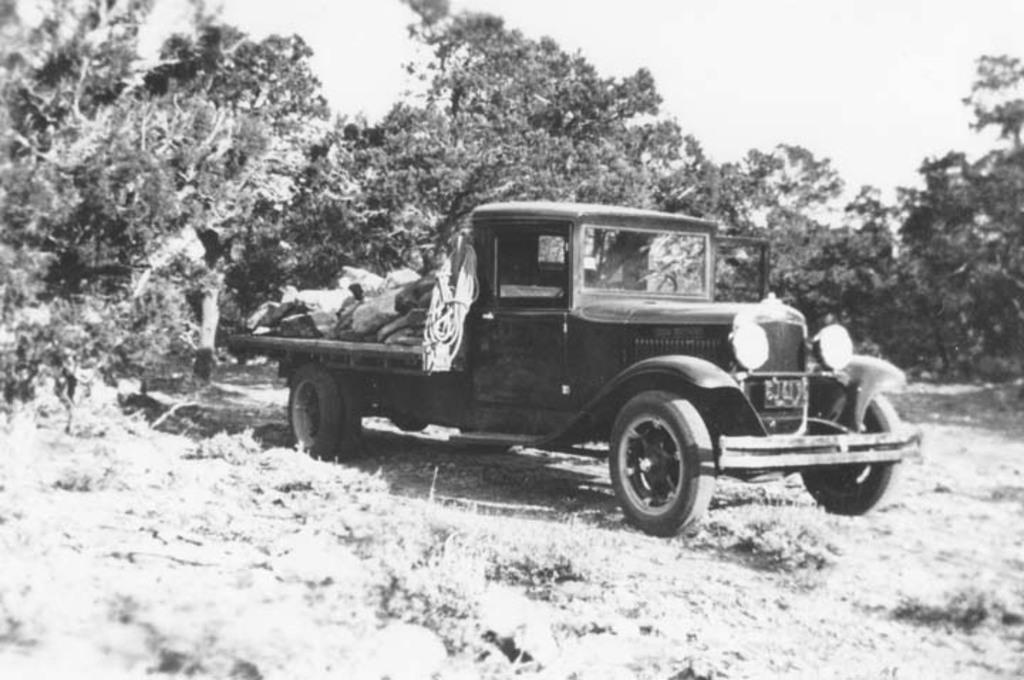In one or two sentences, can you explain what this image depicts? This is a black and white picture, in the image there is a truck on the grassland with trees behind it all over the image and above its sky. 